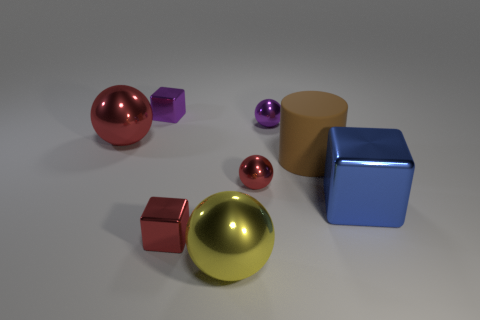Add 2 spheres. How many objects exist? 10 Subtract all cubes. How many objects are left? 5 Add 7 yellow balls. How many yellow balls are left? 8 Add 6 purple rubber balls. How many purple rubber balls exist? 6 Subtract 0 green cylinders. How many objects are left? 8 Subtract all small matte cubes. Subtract all brown rubber cylinders. How many objects are left? 7 